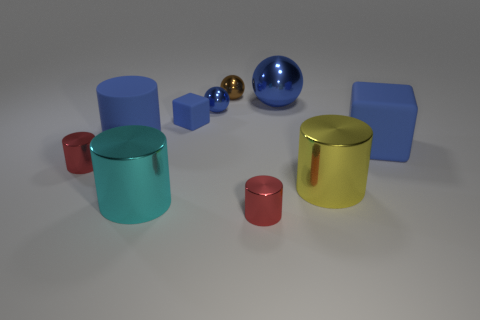What number of objects are in front of the large blue cylinder and to the left of the big cyan object?
Your response must be concise. 1. There is a blue thing right of the big shiny cylinder behind the cyan object; is there a large blue rubber cube behind it?
Make the answer very short. No. What shape is the blue metallic object that is the same size as the yellow object?
Make the answer very short. Sphere. Is there a large object of the same color as the big metal ball?
Provide a short and direct response. Yes. Is the shape of the large blue shiny object the same as the cyan thing?
Keep it short and to the point. No. What number of tiny things are brown metal things or blue metallic balls?
Your answer should be compact. 2. There is a tiny sphere that is the same material as the tiny brown object; what is its color?
Give a very brief answer. Blue. How many other spheres are the same material as the tiny blue ball?
Your answer should be compact. 2. There is a rubber block left of the big rubber cube; is its size the same as the blue rubber cube on the right side of the tiny blue shiny ball?
Ensure brevity in your answer.  No. What is the tiny red thing that is in front of the small metal object on the left side of the tiny blue metallic thing made of?
Offer a very short reply. Metal. 